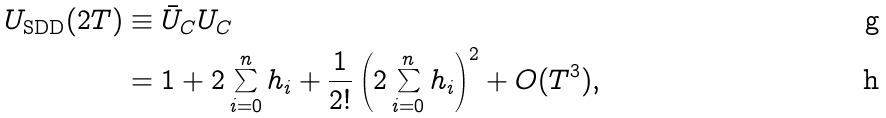<formula> <loc_0><loc_0><loc_500><loc_500>U _ { \text {SDD} } ( 2 T ) & \equiv \bar { U } _ { C } U _ { C } \\ & = 1 + 2 \sum _ { i = 0 } ^ { n } h _ { i } + \frac { 1 } { 2 ! } \left ( 2 \sum _ { i = 0 } ^ { n } h _ { i } \right ) ^ { 2 } + O ( T ^ { 3 } ) ,</formula> 